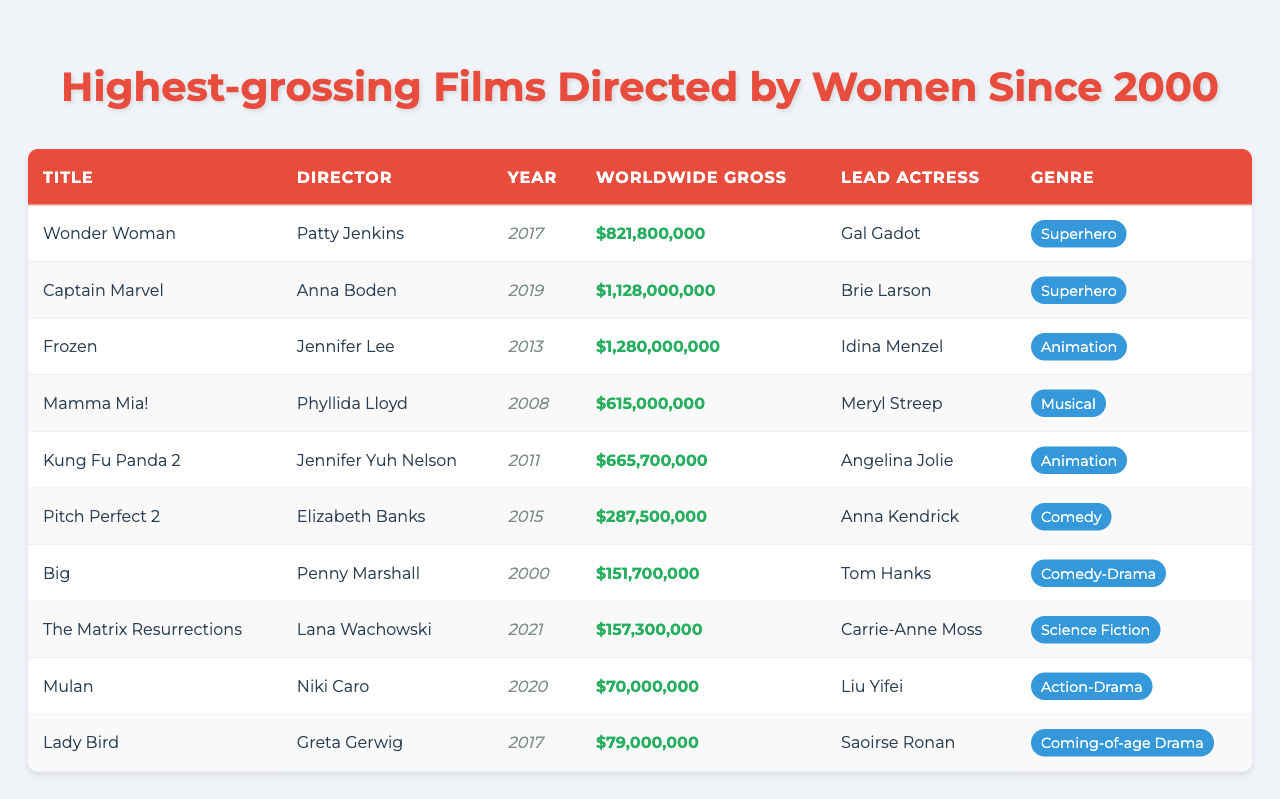What is the highest-grossing film directed by a woman since 2000? The table lists multiple films directed by women. The film "Frozen," directed by Jennifer Lee, has the highest worldwide gross of 1,280,000,000.
Answer: Frozen How much did "Wonder Woman" gross worldwide? According to the table, "Wonder Woman," directed by Patty Jenkins, grossed 821,800,000 worldwide.
Answer: 821,800,000 Which film had the lowest worldwide gross? The table shows that "Mulan," directed by Niki Caro, had the lowest gross at 70,000,000.
Answer: 70,000,000 Who is the director of "Captain Marvel"? "Captain Marvel" is directed by Anna Boden, as stated in the table.
Answer: Anna Boden What is the average worldwide gross of the films listed in the table? To calculate the average, sum the gross figures: 821,800,000 + 1,128,000,000 + 1,280,000,000 + 615,000,000 + 665,700,000 + 287,500,000 + 151,700,000 + 157,300,000 + 70,000,000 + 79,000,000 = 5,440,000,000. There are 10 films, so the average is 5,440,000,000 / 10 = 544,000,000.
Answer: 544,000,000 Which genre has the most films listed in the highest-grossing films directed by women? By reviewing the table, it's clear that the Superhero genre has 2 films: "Wonder Woman" and "Captain Marvel," while other genres have 1 film each.
Answer: Superhero Is "Lady Bird" the highest-grossing film directed by a woman? Looking at the gross figures in the table, "Lady Bird," directed by Greta Gerwig, grossed 79,000,000, which is not the highest; "Frozen" is. Therefore, the statement is false.
Answer: No How many films directed by women grossed over 800 million? The films "Wonder Woman," "Captain Marvel," and "Frozen" grossed over 800 million. Counting these, there are 3 films.
Answer: 3 What is the total worldwide gross of all films directed by women since 2000 in the table? The total is calculated by summing all the gross figures: 821,800,000 + 1,128,000,000 + 1,280,000,000 + 615,000,000 + 665,700,000 + 287,500,000 + 151,700,000 + 157,300,000 + 70,000,000 + 79,000,000 = 5,440,000,000.
Answer: 5,440,000,000 Which film had the earliest release date and what was its worldwide gross? The film "Big," directed by Penny Marshall, was released in 2000 and grossed 151,700,000 according to the table.
Answer: Big, 151,700,000 What percentage of the films listed are in the Animation genre? There are 2 Animation films ("Frozen" and "Kung Fu Panda 2") out of a total of 10 films. Calculating the percentage: (2 / 10) * 100 = 20%.
Answer: 20% 